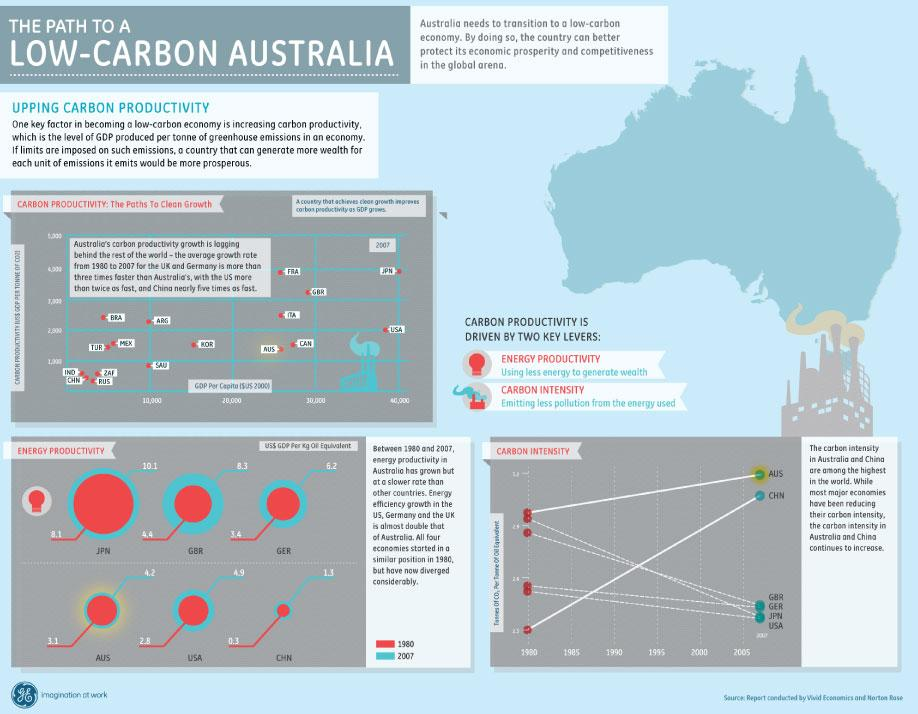Outline some significant characteristics in this image. In 2007, Japan had the highest GDP per capita in terms of carbon productivity among all countries. The country with the lowest energy productivity in the year 1980 was China, represented by the abbreviation CHN. The third lowest value in energy productivity in the year 2007 was 4.9. In 1980, the country with the second highest energy productivity was X. In 2007, the energy productivity of the Great Barrier Reef was 8.3. 